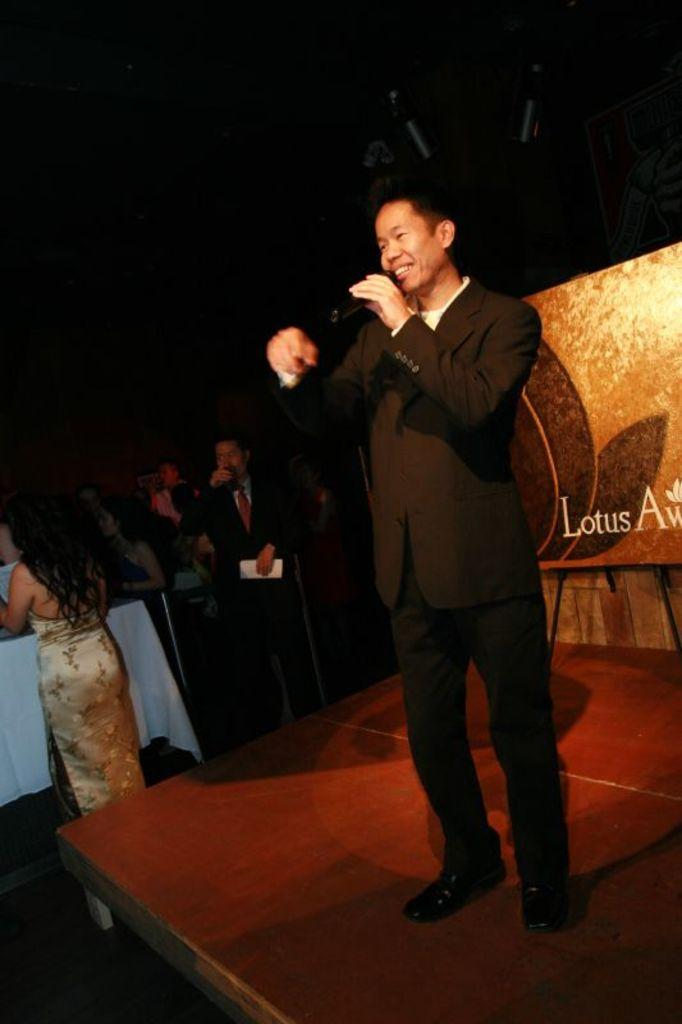What is the man in the center of the image doing? The man is standing in the center of the image and holding a mic. What can be seen in the background of the image? There are people in the background of the image. What is located at the bottom of the image? There is a dais at the bottom of the image. What object is visible in the image besides the man and the people in the background? There is a board visible in the image. What type of clover is growing on the dais in the image? There is no clover visible in the image; the dais mentioned is a platform, not a plant. 